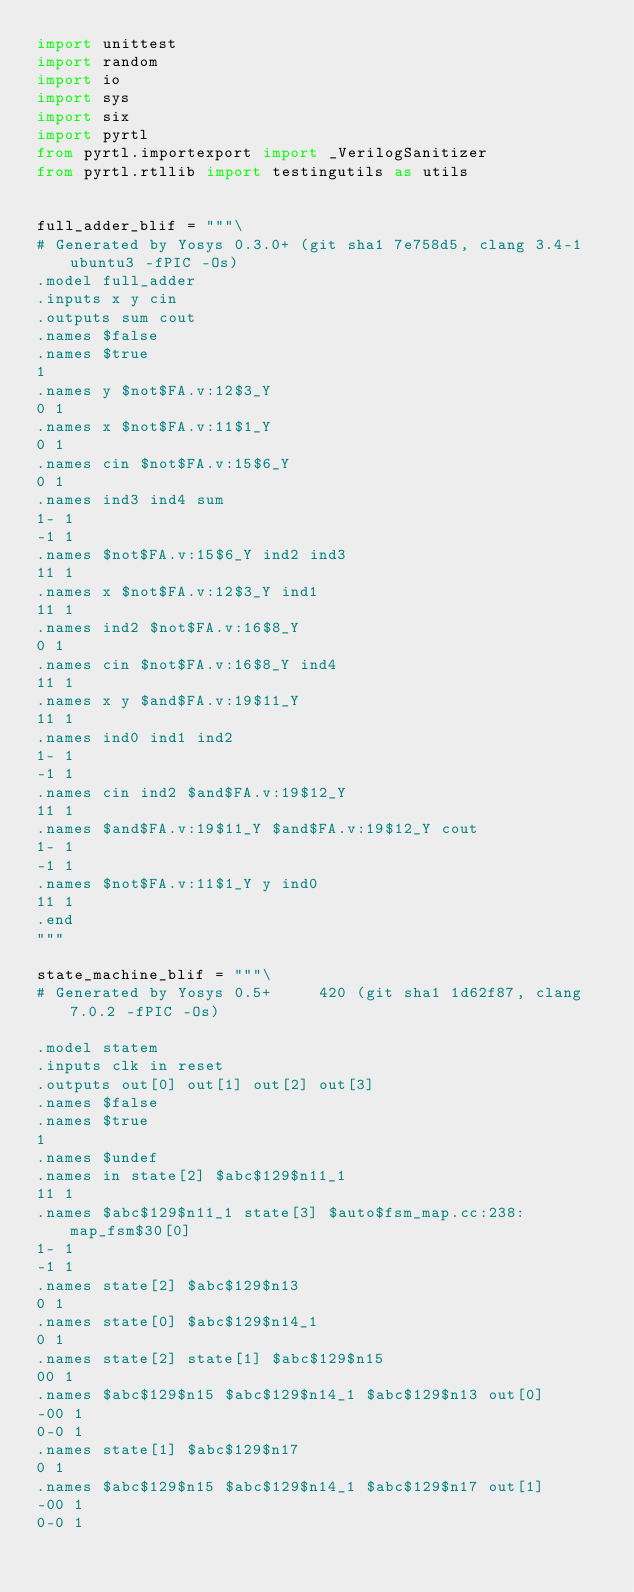Convert code to text. <code><loc_0><loc_0><loc_500><loc_500><_Python_>import unittest
import random
import io
import sys
import six
import pyrtl
from pyrtl.importexport import _VerilogSanitizer
from pyrtl.rtllib import testingutils as utils


full_adder_blif = """\
# Generated by Yosys 0.3.0+ (git sha1 7e758d5, clang 3.4-1ubuntu3 -fPIC -Os)
.model full_adder
.inputs x y cin
.outputs sum cout
.names $false
.names $true
1
.names y $not$FA.v:12$3_Y
0 1
.names x $not$FA.v:11$1_Y
0 1
.names cin $not$FA.v:15$6_Y
0 1
.names ind3 ind4 sum
1- 1
-1 1
.names $not$FA.v:15$6_Y ind2 ind3
11 1
.names x $not$FA.v:12$3_Y ind1
11 1
.names ind2 $not$FA.v:16$8_Y
0 1
.names cin $not$FA.v:16$8_Y ind4
11 1
.names x y $and$FA.v:19$11_Y
11 1
.names ind0 ind1 ind2
1- 1
-1 1
.names cin ind2 $and$FA.v:19$12_Y
11 1
.names $and$FA.v:19$11_Y $and$FA.v:19$12_Y cout
1- 1
-1 1
.names $not$FA.v:11$1_Y y ind0
11 1
.end
"""

state_machine_blif = """\
# Generated by Yosys 0.5+     420 (git sha1 1d62f87, clang 7.0.2 -fPIC -Os)

.model statem
.inputs clk in reset
.outputs out[0] out[1] out[2] out[3]
.names $false
.names $true
1
.names $undef
.names in state[2] $abc$129$n11_1
11 1
.names $abc$129$n11_1 state[3] $auto$fsm_map.cc:238:map_fsm$30[0]
1- 1
-1 1
.names state[2] $abc$129$n13
0 1
.names state[0] $abc$129$n14_1
0 1
.names state[2] state[1] $abc$129$n15
00 1
.names $abc$129$n15 $abc$129$n14_1 $abc$129$n13 out[0]
-00 1
0-0 1
.names state[1] $abc$129$n17
0 1
.names $abc$129$n15 $abc$129$n14_1 $abc$129$n17 out[1]
-00 1
0-0 1</code> 